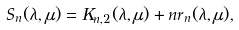Convert formula to latex. <formula><loc_0><loc_0><loc_500><loc_500>S _ { n } ( \lambda , \mu ) = K _ { n , 2 } ( \lambda , \mu ) + n r _ { n } ( \lambda , \mu ) ,</formula> 